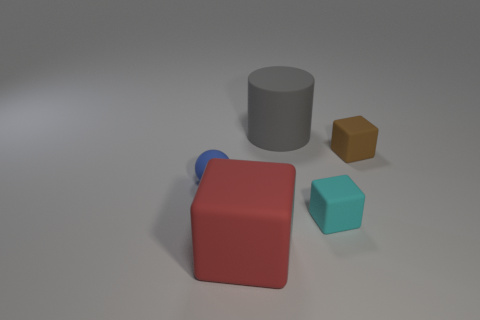Subtract all small brown cubes. How many cubes are left? 2 Add 4 green rubber blocks. How many objects exist? 9 Subtract all brown cubes. How many cubes are left? 2 Subtract all cubes. How many objects are left? 2 Subtract 2 cubes. How many cubes are left? 1 Subtract all brown blocks. Subtract all brown spheres. How many blocks are left? 2 Subtract all blue spheres. How many cyan cubes are left? 1 Subtract all cyan matte cylinders. Subtract all tiny objects. How many objects are left? 2 Add 1 cyan matte things. How many cyan matte things are left? 2 Add 3 matte cylinders. How many matte cylinders exist? 4 